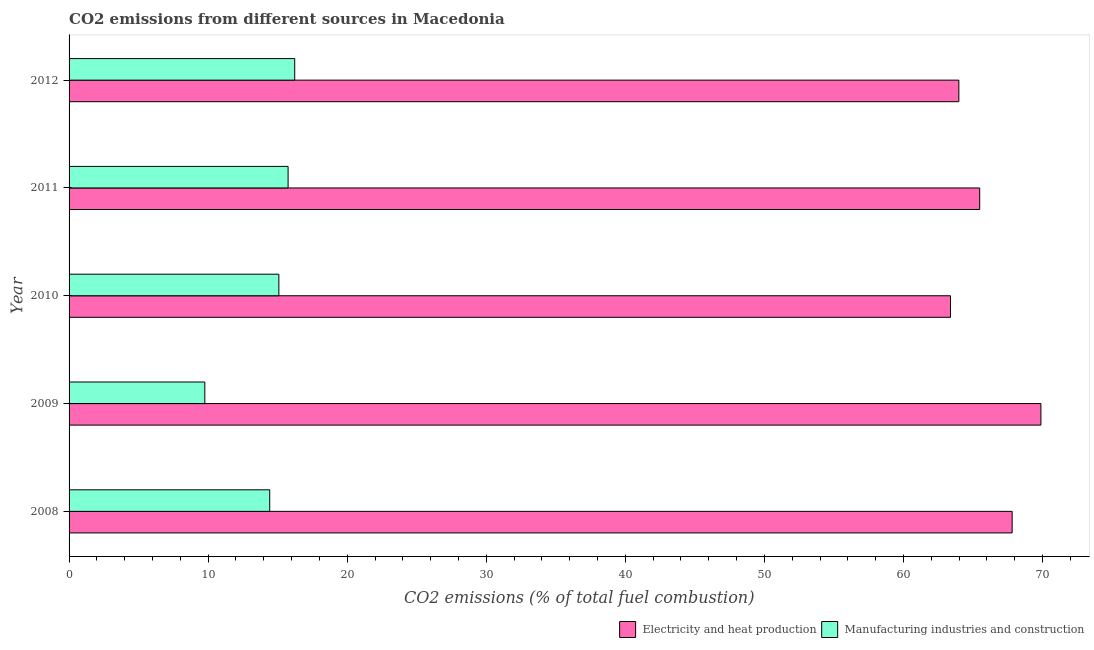How many different coloured bars are there?
Provide a short and direct response. 2. How many groups of bars are there?
Make the answer very short. 5. How many bars are there on the 1st tick from the top?
Provide a succinct answer. 2. In how many cases, is the number of bars for a given year not equal to the number of legend labels?
Offer a terse response. 0. What is the co2 emissions due to manufacturing industries in 2011?
Your answer should be very brief. 15.75. Across all years, what is the maximum co2 emissions due to electricity and heat production?
Your response must be concise. 69.88. Across all years, what is the minimum co2 emissions due to electricity and heat production?
Provide a succinct answer. 63.38. In which year was the co2 emissions due to electricity and heat production maximum?
Make the answer very short. 2009. In which year was the co2 emissions due to manufacturing industries minimum?
Offer a terse response. 2009. What is the total co2 emissions due to manufacturing industries in the graph?
Offer a very short reply. 71.25. What is the difference between the co2 emissions due to electricity and heat production in 2008 and that in 2009?
Keep it short and to the point. -2.07. What is the difference between the co2 emissions due to electricity and heat production in 2011 and the co2 emissions due to manufacturing industries in 2012?
Your answer should be very brief. 49.25. What is the average co2 emissions due to manufacturing industries per year?
Provide a short and direct response. 14.25. In the year 2012, what is the difference between the co2 emissions due to manufacturing industries and co2 emissions due to electricity and heat production?
Keep it short and to the point. -47.76. Is the difference between the co2 emissions due to manufacturing industries in 2008 and 2009 greater than the difference between the co2 emissions due to electricity and heat production in 2008 and 2009?
Your answer should be very brief. Yes. What is the difference between the highest and the second highest co2 emissions due to electricity and heat production?
Provide a succinct answer. 2.07. What is the difference between the highest and the lowest co2 emissions due to manufacturing industries?
Provide a succinct answer. 6.46. In how many years, is the co2 emissions due to manufacturing industries greater than the average co2 emissions due to manufacturing industries taken over all years?
Make the answer very short. 4. What does the 1st bar from the top in 2008 represents?
Offer a terse response. Manufacturing industries and construction. What does the 2nd bar from the bottom in 2012 represents?
Provide a succinct answer. Manufacturing industries and construction. How many years are there in the graph?
Your answer should be very brief. 5. Are the values on the major ticks of X-axis written in scientific E-notation?
Offer a terse response. No. Does the graph contain any zero values?
Keep it short and to the point. No. What is the title of the graph?
Provide a succinct answer. CO2 emissions from different sources in Macedonia. Does "Methane" appear as one of the legend labels in the graph?
Provide a short and direct response. No. What is the label or title of the X-axis?
Your answer should be compact. CO2 emissions (% of total fuel combustion). What is the label or title of the Y-axis?
Your answer should be compact. Year. What is the CO2 emissions (% of total fuel combustion) of Electricity and heat production in 2008?
Make the answer very short. 67.81. What is the CO2 emissions (% of total fuel combustion) in Manufacturing industries and construction in 2008?
Your answer should be compact. 14.43. What is the CO2 emissions (% of total fuel combustion) of Electricity and heat production in 2009?
Offer a very short reply. 69.88. What is the CO2 emissions (% of total fuel combustion) of Manufacturing industries and construction in 2009?
Offer a terse response. 9.76. What is the CO2 emissions (% of total fuel combustion) of Electricity and heat production in 2010?
Your answer should be very brief. 63.38. What is the CO2 emissions (% of total fuel combustion) of Manufacturing industries and construction in 2010?
Give a very brief answer. 15.09. What is the CO2 emissions (% of total fuel combustion) of Electricity and heat production in 2011?
Offer a terse response. 65.48. What is the CO2 emissions (% of total fuel combustion) in Manufacturing industries and construction in 2011?
Make the answer very short. 15.75. What is the CO2 emissions (% of total fuel combustion) in Electricity and heat production in 2012?
Offer a terse response. 63.98. What is the CO2 emissions (% of total fuel combustion) in Manufacturing industries and construction in 2012?
Ensure brevity in your answer.  16.23. Across all years, what is the maximum CO2 emissions (% of total fuel combustion) in Electricity and heat production?
Keep it short and to the point. 69.88. Across all years, what is the maximum CO2 emissions (% of total fuel combustion) of Manufacturing industries and construction?
Keep it short and to the point. 16.23. Across all years, what is the minimum CO2 emissions (% of total fuel combustion) of Electricity and heat production?
Keep it short and to the point. 63.38. Across all years, what is the minimum CO2 emissions (% of total fuel combustion) in Manufacturing industries and construction?
Keep it short and to the point. 9.76. What is the total CO2 emissions (% of total fuel combustion) in Electricity and heat production in the graph?
Your answer should be very brief. 330.54. What is the total CO2 emissions (% of total fuel combustion) of Manufacturing industries and construction in the graph?
Offer a terse response. 71.25. What is the difference between the CO2 emissions (% of total fuel combustion) of Electricity and heat production in 2008 and that in 2009?
Offer a very short reply. -2.07. What is the difference between the CO2 emissions (% of total fuel combustion) of Manufacturing industries and construction in 2008 and that in 2009?
Keep it short and to the point. 4.67. What is the difference between the CO2 emissions (% of total fuel combustion) of Electricity and heat production in 2008 and that in 2010?
Your answer should be compact. 4.43. What is the difference between the CO2 emissions (% of total fuel combustion) of Manufacturing industries and construction in 2008 and that in 2010?
Provide a succinct answer. -0.66. What is the difference between the CO2 emissions (% of total fuel combustion) of Electricity and heat production in 2008 and that in 2011?
Provide a succinct answer. 2.33. What is the difference between the CO2 emissions (% of total fuel combustion) in Manufacturing industries and construction in 2008 and that in 2011?
Offer a very short reply. -1.32. What is the difference between the CO2 emissions (% of total fuel combustion) of Electricity and heat production in 2008 and that in 2012?
Your answer should be compact. 3.83. What is the difference between the CO2 emissions (% of total fuel combustion) in Manufacturing industries and construction in 2008 and that in 2012?
Provide a short and direct response. -1.8. What is the difference between the CO2 emissions (% of total fuel combustion) of Electricity and heat production in 2009 and that in 2010?
Provide a short and direct response. 6.5. What is the difference between the CO2 emissions (% of total fuel combustion) of Manufacturing industries and construction in 2009 and that in 2010?
Provide a short and direct response. -5.32. What is the difference between the CO2 emissions (% of total fuel combustion) in Electricity and heat production in 2009 and that in 2011?
Give a very brief answer. 4.4. What is the difference between the CO2 emissions (% of total fuel combustion) in Manufacturing industries and construction in 2009 and that in 2011?
Your answer should be compact. -5.99. What is the difference between the CO2 emissions (% of total fuel combustion) in Electricity and heat production in 2009 and that in 2012?
Give a very brief answer. 5.9. What is the difference between the CO2 emissions (% of total fuel combustion) of Manufacturing industries and construction in 2009 and that in 2012?
Make the answer very short. -6.46. What is the difference between the CO2 emissions (% of total fuel combustion) in Electricity and heat production in 2010 and that in 2011?
Offer a terse response. -2.1. What is the difference between the CO2 emissions (% of total fuel combustion) of Manufacturing industries and construction in 2010 and that in 2011?
Ensure brevity in your answer.  -0.66. What is the difference between the CO2 emissions (% of total fuel combustion) in Electricity and heat production in 2010 and that in 2012?
Your answer should be very brief. -0.6. What is the difference between the CO2 emissions (% of total fuel combustion) of Manufacturing industries and construction in 2010 and that in 2012?
Offer a very short reply. -1.14. What is the difference between the CO2 emissions (% of total fuel combustion) of Electricity and heat production in 2011 and that in 2012?
Provide a short and direct response. 1.5. What is the difference between the CO2 emissions (% of total fuel combustion) of Manufacturing industries and construction in 2011 and that in 2012?
Provide a succinct answer. -0.48. What is the difference between the CO2 emissions (% of total fuel combustion) in Electricity and heat production in 2008 and the CO2 emissions (% of total fuel combustion) in Manufacturing industries and construction in 2009?
Keep it short and to the point. 58.05. What is the difference between the CO2 emissions (% of total fuel combustion) in Electricity and heat production in 2008 and the CO2 emissions (% of total fuel combustion) in Manufacturing industries and construction in 2010?
Ensure brevity in your answer.  52.73. What is the difference between the CO2 emissions (% of total fuel combustion) of Electricity and heat production in 2008 and the CO2 emissions (% of total fuel combustion) of Manufacturing industries and construction in 2011?
Provide a succinct answer. 52.06. What is the difference between the CO2 emissions (% of total fuel combustion) in Electricity and heat production in 2008 and the CO2 emissions (% of total fuel combustion) in Manufacturing industries and construction in 2012?
Your answer should be compact. 51.59. What is the difference between the CO2 emissions (% of total fuel combustion) of Electricity and heat production in 2009 and the CO2 emissions (% of total fuel combustion) of Manufacturing industries and construction in 2010?
Provide a short and direct response. 54.8. What is the difference between the CO2 emissions (% of total fuel combustion) in Electricity and heat production in 2009 and the CO2 emissions (% of total fuel combustion) in Manufacturing industries and construction in 2011?
Your answer should be compact. 54.13. What is the difference between the CO2 emissions (% of total fuel combustion) in Electricity and heat production in 2009 and the CO2 emissions (% of total fuel combustion) in Manufacturing industries and construction in 2012?
Your response must be concise. 53.66. What is the difference between the CO2 emissions (% of total fuel combustion) of Electricity and heat production in 2010 and the CO2 emissions (% of total fuel combustion) of Manufacturing industries and construction in 2011?
Your response must be concise. 47.63. What is the difference between the CO2 emissions (% of total fuel combustion) of Electricity and heat production in 2010 and the CO2 emissions (% of total fuel combustion) of Manufacturing industries and construction in 2012?
Offer a terse response. 47.16. What is the difference between the CO2 emissions (% of total fuel combustion) of Electricity and heat production in 2011 and the CO2 emissions (% of total fuel combustion) of Manufacturing industries and construction in 2012?
Your answer should be compact. 49.25. What is the average CO2 emissions (% of total fuel combustion) in Electricity and heat production per year?
Give a very brief answer. 66.11. What is the average CO2 emissions (% of total fuel combustion) of Manufacturing industries and construction per year?
Make the answer very short. 14.25. In the year 2008, what is the difference between the CO2 emissions (% of total fuel combustion) in Electricity and heat production and CO2 emissions (% of total fuel combustion) in Manufacturing industries and construction?
Make the answer very short. 53.39. In the year 2009, what is the difference between the CO2 emissions (% of total fuel combustion) of Electricity and heat production and CO2 emissions (% of total fuel combustion) of Manufacturing industries and construction?
Keep it short and to the point. 60.12. In the year 2010, what is the difference between the CO2 emissions (% of total fuel combustion) in Electricity and heat production and CO2 emissions (% of total fuel combustion) in Manufacturing industries and construction?
Provide a succinct answer. 48.3. In the year 2011, what is the difference between the CO2 emissions (% of total fuel combustion) in Electricity and heat production and CO2 emissions (% of total fuel combustion) in Manufacturing industries and construction?
Offer a terse response. 49.73. In the year 2012, what is the difference between the CO2 emissions (% of total fuel combustion) of Electricity and heat production and CO2 emissions (% of total fuel combustion) of Manufacturing industries and construction?
Keep it short and to the point. 47.76. What is the ratio of the CO2 emissions (% of total fuel combustion) in Electricity and heat production in 2008 to that in 2009?
Provide a succinct answer. 0.97. What is the ratio of the CO2 emissions (% of total fuel combustion) in Manufacturing industries and construction in 2008 to that in 2009?
Your answer should be very brief. 1.48. What is the ratio of the CO2 emissions (% of total fuel combustion) of Electricity and heat production in 2008 to that in 2010?
Provide a short and direct response. 1.07. What is the ratio of the CO2 emissions (% of total fuel combustion) in Manufacturing industries and construction in 2008 to that in 2010?
Ensure brevity in your answer.  0.96. What is the ratio of the CO2 emissions (% of total fuel combustion) of Electricity and heat production in 2008 to that in 2011?
Make the answer very short. 1.04. What is the ratio of the CO2 emissions (% of total fuel combustion) in Manufacturing industries and construction in 2008 to that in 2011?
Your response must be concise. 0.92. What is the ratio of the CO2 emissions (% of total fuel combustion) of Electricity and heat production in 2008 to that in 2012?
Provide a short and direct response. 1.06. What is the ratio of the CO2 emissions (% of total fuel combustion) of Manufacturing industries and construction in 2008 to that in 2012?
Ensure brevity in your answer.  0.89. What is the ratio of the CO2 emissions (% of total fuel combustion) in Electricity and heat production in 2009 to that in 2010?
Offer a terse response. 1.1. What is the ratio of the CO2 emissions (% of total fuel combustion) of Manufacturing industries and construction in 2009 to that in 2010?
Offer a very short reply. 0.65. What is the ratio of the CO2 emissions (% of total fuel combustion) in Electricity and heat production in 2009 to that in 2011?
Your answer should be very brief. 1.07. What is the ratio of the CO2 emissions (% of total fuel combustion) in Manufacturing industries and construction in 2009 to that in 2011?
Your response must be concise. 0.62. What is the ratio of the CO2 emissions (% of total fuel combustion) in Electricity and heat production in 2009 to that in 2012?
Make the answer very short. 1.09. What is the ratio of the CO2 emissions (% of total fuel combustion) of Manufacturing industries and construction in 2009 to that in 2012?
Give a very brief answer. 0.6. What is the ratio of the CO2 emissions (% of total fuel combustion) of Electricity and heat production in 2010 to that in 2011?
Provide a succinct answer. 0.97. What is the ratio of the CO2 emissions (% of total fuel combustion) in Manufacturing industries and construction in 2010 to that in 2011?
Offer a very short reply. 0.96. What is the ratio of the CO2 emissions (% of total fuel combustion) in Electricity and heat production in 2010 to that in 2012?
Your response must be concise. 0.99. What is the ratio of the CO2 emissions (% of total fuel combustion) of Manufacturing industries and construction in 2010 to that in 2012?
Offer a very short reply. 0.93. What is the ratio of the CO2 emissions (% of total fuel combustion) in Electricity and heat production in 2011 to that in 2012?
Your response must be concise. 1.02. What is the ratio of the CO2 emissions (% of total fuel combustion) of Manufacturing industries and construction in 2011 to that in 2012?
Provide a short and direct response. 0.97. What is the difference between the highest and the second highest CO2 emissions (% of total fuel combustion) of Electricity and heat production?
Provide a short and direct response. 2.07. What is the difference between the highest and the second highest CO2 emissions (% of total fuel combustion) in Manufacturing industries and construction?
Ensure brevity in your answer.  0.48. What is the difference between the highest and the lowest CO2 emissions (% of total fuel combustion) in Electricity and heat production?
Provide a short and direct response. 6.5. What is the difference between the highest and the lowest CO2 emissions (% of total fuel combustion) in Manufacturing industries and construction?
Offer a terse response. 6.46. 